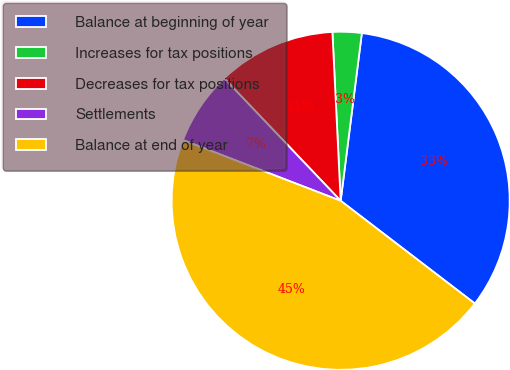Convert chart. <chart><loc_0><loc_0><loc_500><loc_500><pie_chart><fcel>Balance at beginning of year<fcel>Increases for tax positions<fcel>Decreases for tax positions<fcel>Settlements<fcel>Balance at end of year<nl><fcel>33.4%<fcel>2.78%<fcel>11.32%<fcel>7.05%<fcel>45.45%<nl></chart> 